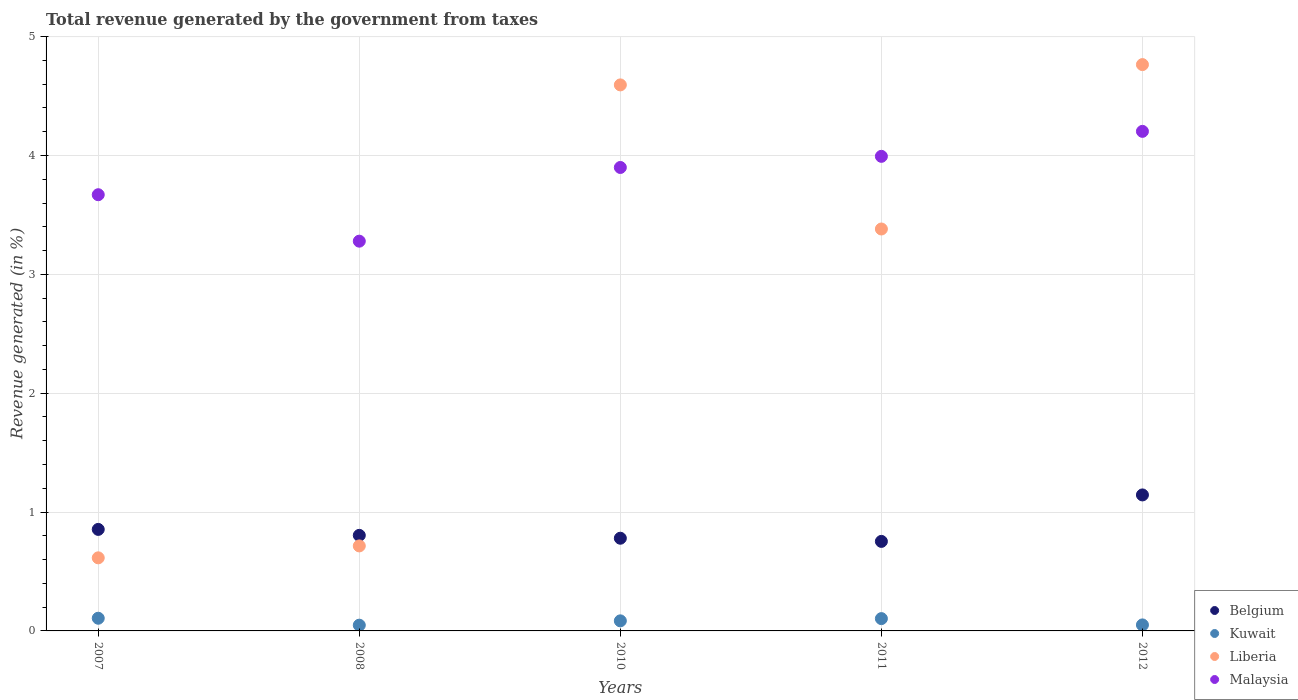Is the number of dotlines equal to the number of legend labels?
Provide a short and direct response. Yes. What is the total revenue generated in Malaysia in 2012?
Provide a short and direct response. 4.2. Across all years, what is the maximum total revenue generated in Belgium?
Give a very brief answer. 1.14. Across all years, what is the minimum total revenue generated in Kuwait?
Keep it short and to the point. 0.05. In which year was the total revenue generated in Belgium minimum?
Offer a terse response. 2011. What is the total total revenue generated in Liberia in the graph?
Provide a succinct answer. 14.07. What is the difference between the total revenue generated in Malaysia in 2008 and that in 2010?
Make the answer very short. -0.62. What is the difference between the total revenue generated in Belgium in 2011 and the total revenue generated in Kuwait in 2012?
Provide a succinct answer. 0.7. What is the average total revenue generated in Malaysia per year?
Your answer should be very brief. 3.81. In the year 2012, what is the difference between the total revenue generated in Malaysia and total revenue generated in Kuwait?
Ensure brevity in your answer.  4.15. In how many years, is the total revenue generated in Belgium greater than 2 %?
Ensure brevity in your answer.  0. What is the ratio of the total revenue generated in Kuwait in 2011 to that in 2012?
Your answer should be compact. 2.05. Is the total revenue generated in Belgium in 2008 less than that in 2012?
Your answer should be very brief. Yes. What is the difference between the highest and the second highest total revenue generated in Malaysia?
Make the answer very short. 0.21. What is the difference between the highest and the lowest total revenue generated in Kuwait?
Keep it short and to the point. 0.06. Is the sum of the total revenue generated in Belgium in 2011 and 2012 greater than the maximum total revenue generated in Malaysia across all years?
Offer a very short reply. No. Is it the case that in every year, the sum of the total revenue generated in Liberia and total revenue generated in Kuwait  is greater than the total revenue generated in Malaysia?
Your answer should be very brief. No. Is the total revenue generated in Belgium strictly less than the total revenue generated in Malaysia over the years?
Give a very brief answer. Yes. How many years are there in the graph?
Your answer should be compact. 5. Does the graph contain any zero values?
Offer a terse response. No. Does the graph contain grids?
Keep it short and to the point. Yes. Where does the legend appear in the graph?
Ensure brevity in your answer.  Bottom right. What is the title of the graph?
Provide a short and direct response. Total revenue generated by the government from taxes. What is the label or title of the Y-axis?
Your response must be concise. Revenue generated (in %). What is the Revenue generated (in %) of Belgium in 2007?
Your answer should be compact. 0.85. What is the Revenue generated (in %) of Kuwait in 2007?
Provide a short and direct response. 0.11. What is the Revenue generated (in %) of Liberia in 2007?
Your answer should be compact. 0.61. What is the Revenue generated (in %) of Malaysia in 2007?
Your answer should be very brief. 3.67. What is the Revenue generated (in %) of Belgium in 2008?
Offer a very short reply. 0.8. What is the Revenue generated (in %) of Kuwait in 2008?
Provide a succinct answer. 0.05. What is the Revenue generated (in %) in Liberia in 2008?
Give a very brief answer. 0.72. What is the Revenue generated (in %) in Malaysia in 2008?
Keep it short and to the point. 3.28. What is the Revenue generated (in %) of Belgium in 2010?
Make the answer very short. 0.78. What is the Revenue generated (in %) of Kuwait in 2010?
Provide a short and direct response. 0.08. What is the Revenue generated (in %) in Liberia in 2010?
Keep it short and to the point. 4.59. What is the Revenue generated (in %) in Malaysia in 2010?
Make the answer very short. 3.9. What is the Revenue generated (in %) of Belgium in 2011?
Give a very brief answer. 0.75. What is the Revenue generated (in %) of Kuwait in 2011?
Keep it short and to the point. 0.1. What is the Revenue generated (in %) of Liberia in 2011?
Give a very brief answer. 3.38. What is the Revenue generated (in %) of Malaysia in 2011?
Provide a short and direct response. 3.99. What is the Revenue generated (in %) of Belgium in 2012?
Ensure brevity in your answer.  1.14. What is the Revenue generated (in %) in Kuwait in 2012?
Provide a succinct answer. 0.05. What is the Revenue generated (in %) of Liberia in 2012?
Keep it short and to the point. 4.76. What is the Revenue generated (in %) of Malaysia in 2012?
Offer a terse response. 4.2. Across all years, what is the maximum Revenue generated (in %) of Belgium?
Your answer should be compact. 1.14. Across all years, what is the maximum Revenue generated (in %) in Kuwait?
Ensure brevity in your answer.  0.11. Across all years, what is the maximum Revenue generated (in %) in Liberia?
Keep it short and to the point. 4.76. Across all years, what is the maximum Revenue generated (in %) in Malaysia?
Your answer should be compact. 4.2. Across all years, what is the minimum Revenue generated (in %) of Belgium?
Offer a very short reply. 0.75. Across all years, what is the minimum Revenue generated (in %) in Kuwait?
Ensure brevity in your answer.  0.05. Across all years, what is the minimum Revenue generated (in %) of Liberia?
Keep it short and to the point. 0.61. Across all years, what is the minimum Revenue generated (in %) of Malaysia?
Your response must be concise. 3.28. What is the total Revenue generated (in %) of Belgium in the graph?
Keep it short and to the point. 4.34. What is the total Revenue generated (in %) of Kuwait in the graph?
Provide a succinct answer. 0.39. What is the total Revenue generated (in %) of Liberia in the graph?
Your answer should be very brief. 14.07. What is the total Revenue generated (in %) of Malaysia in the graph?
Make the answer very short. 19.04. What is the difference between the Revenue generated (in %) of Belgium in 2007 and that in 2008?
Ensure brevity in your answer.  0.05. What is the difference between the Revenue generated (in %) of Kuwait in 2007 and that in 2008?
Keep it short and to the point. 0.06. What is the difference between the Revenue generated (in %) of Liberia in 2007 and that in 2008?
Offer a terse response. -0.1. What is the difference between the Revenue generated (in %) in Malaysia in 2007 and that in 2008?
Your response must be concise. 0.39. What is the difference between the Revenue generated (in %) in Belgium in 2007 and that in 2010?
Keep it short and to the point. 0.07. What is the difference between the Revenue generated (in %) of Kuwait in 2007 and that in 2010?
Your answer should be very brief. 0.02. What is the difference between the Revenue generated (in %) of Liberia in 2007 and that in 2010?
Your answer should be compact. -3.98. What is the difference between the Revenue generated (in %) of Malaysia in 2007 and that in 2010?
Provide a short and direct response. -0.23. What is the difference between the Revenue generated (in %) of Belgium in 2007 and that in 2011?
Offer a very short reply. 0.1. What is the difference between the Revenue generated (in %) in Kuwait in 2007 and that in 2011?
Make the answer very short. 0. What is the difference between the Revenue generated (in %) in Liberia in 2007 and that in 2011?
Your answer should be compact. -2.77. What is the difference between the Revenue generated (in %) of Malaysia in 2007 and that in 2011?
Give a very brief answer. -0.32. What is the difference between the Revenue generated (in %) of Belgium in 2007 and that in 2012?
Provide a short and direct response. -0.29. What is the difference between the Revenue generated (in %) in Kuwait in 2007 and that in 2012?
Give a very brief answer. 0.06. What is the difference between the Revenue generated (in %) of Liberia in 2007 and that in 2012?
Make the answer very short. -4.15. What is the difference between the Revenue generated (in %) of Malaysia in 2007 and that in 2012?
Give a very brief answer. -0.53. What is the difference between the Revenue generated (in %) in Belgium in 2008 and that in 2010?
Provide a succinct answer. 0.02. What is the difference between the Revenue generated (in %) of Kuwait in 2008 and that in 2010?
Provide a short and direct response. -0.04. What is the difference between the Revenue generated (in %) of Liberia in 2008 and that in 2010?
Make the answer very short. -3.88. What is the difference between the Revenue generated (in %) in Malaysia in 2008 and that in 2010?
Offer a terse response. -0.62. What is the difference between the Revenue generated (in %) in Belgium in 2008 and that in 2011?
Provide a short and direct response. 0.05. What is the difference between the Revenue generated (in %) in Kuwait in 2008 and that in 2011?
Offer a very short reply. -0.06. What is the difference between the Revenue generated (in %) of Liberia in 2008 and that in 2011?
Provide a short and direct response. -2.67. What is the difference between the Revenue generated (in %) of Malaysia in 2008 and that in 2011?
Make the answer very short. -0.71. What is the difference between the Revenue generated (in %) in Belgium in 2008 and that in 2012?
Give a very brief answer. -0.34. What is the difference between the Revenue generated (in %) in Kuwait in 2008 and that in 2012?
Give a very brief answer. -0. What is the difference between the Revenue generated (in %) in Liberia in 2008 and that in 2012?
Your answer should be very brief. -4.05. What is the difference between the Revenue generated (in %) in Malaysia in 2008 and that in 2012?
Offer a terse response. -0.92. What is the difference between the Revenue generated (in %) in Belgium in 2010 and that in 2011?
Provide a succinct answer. 0.03. What is the difference between the Revenue generated (in %) in Kuwait in 2010 and that in 2011?
Make the answer very short. -0.02. What is the difference between the Revenue generated (in %) in Liberia in 2010 and that in 2011?
Provide a short and direct response. 1.21. What is the difference between the Revenue generated (in %) in Malaysia in 2010 and that in 2011?
Your answer should be very brief. -0.09. What is the difference between the Revenue generated (in %) in Belgium in 2010 and that in 2012?
Ensure brevity in your answer.  -0.36. What is the difference between the Revenue generated (in %) of Kuwait in 2010 and that in 2012?
Your response must be concise. 0.03. What is the difference between the Revenue generated (in %) of Liberia in 2010 and that in 2012?
Provide a succinct answer. -0.17. What is the difference between the Revenue generated (in %) in Malaysia in 2010 and that in 2012?
Keep it short and to the point. -0.3. What is the difference between the Revenue generated (in %) in Belgium in 2011 and that in 2012?
Provide a succinct answer. -0.39. What is the difference between the Revenue generated (in %) of Kuwait in 2011 and that in 2012?
Your answer should be compact. 0.05. What is the difference between the Revenue generated (in %) of Liberia in 2011 and that in 2012?
Keep it short and to the point. -1.38. What is the difference between the Revenue generated (in %) of Malaysia in 2011 and that in 2012?
Your response must be concise. -0.21. What is the difference between the Revenue generated (in %) in Belgium in 2007 and the Revenue generated (in %) in Kuwait in 2008?
Your answer should be very brief. 0.81. What is the difference between the Revenue generated (in %) of Belgium in 2007 and the Revenue generated (in %) of Liberia in 2008?
Your response must be concise. 0.14. What is the difference between the Revenue generated (in %) of Belgium in 2007 and the Revenue generated (in %) of Malaysia in 2008?
Your answer should be compact. -2.42. What is the difference between the Revenue generated (in %) of Kuwait in 2007 and the Revenue generated (in %) of Liberia in 2008?
Provide a succinct answer. -0.61. What is the difference between the Revenue generated (in %) in Kuwait in 2007 and the Revenue generated (in %) in Malaysia in 2008?
Provide a short and direct response. -3.17. What is the difference between the Revenue generated (in %) of Liberia in 2007 and the Revenue generated (in %) of Malaysia in 2008?
Your answer should be compact. -2.66. What is the difference between the Revenue generated (in %) of Belgium in 2007 and the Revenue generated (in %) of Kuwait in 2010?
Your response must be concise. 0.77. What is the difference between the Revenue generated (in %) in Belgium in 2007 and the Revenue generated (in %) in Liberia in 2010?
Keep it short and to the point. -3.74. What is the difference between the Revenue generated (in %) in Belgium in 2007 and the Revenue generated (in %) in Malaysia in 2010?
Make the answer very short. -3.04. What is the difference between the Revenue generated (in %) in Kuwait in 2007 and the Revenue generated (in %) in Liberia in 2010?
Keep it short and to the point. -4.49. What is the difference between the Revenue generated (in %) of Kuwait in 2007 and the Revenue generated (in %) of Malaysia in 2010?
Your response must be concise. -3.79. What is the difference between the Revenue generated (in %) of Liberia in 2007 and the Revenue generated (in %) of Malaysia in 2010?
Offer a terse response. -3.28. What is the difference between the Revenue generated (in %) of Belgium in 2007 and the Revenue generated (in %) of Kuwait in 2011?
Keep it short and to the point. 0.75. What is the difference between the Revenue generated (in %) in Belgium in 2007 and the Revenue generated (in %) in Liberia in 2011?
Your answer should be compact. -2.53. What is the difference between the Revenue generated (in %) of Belgium in 2007 and the Revenue generated (in %) of Malaysia in 2011?
Ensure brevity in your answer.  -3.14. What is the difference between the Revenue generated (in %) of Kuwait in 2007 and the Revenue generated (in %) of Liberia in 2011?
Offer a very short reply. -3.27. What is the difference between the Revenue generated (in %) in Kuwait in 2007 and the Revenue generated (in %) in Malaysia in 2011?
Offer a very short reply. -3.89. What is the difference between the Revenue generated (in %) in Liberia in 2007 and the Revenue generated (in %) in Malaysia in 2011?
Offer a terse response. -3.38. What is the difference between the Revenue generated (in %) in Belgium in 2007 and the Revenue generated (in %) in Kuwait in 2012?
Offer a very short reply. 0.8. What is the difference between the Revenue generated (in %) of Belgium in 2007 and the Revenue generated (in %) of Liberia in 2012?
Provide a succinct answer. -3.91. What is the difference between the Revenue generated (in %) of Belgium in 2007 and the Revenue generated (in %) of Malaysia in 2012?
Ensure brevity in your answer.  -3.35. What is the difference between the Revenue generated (in %) of Kuwait in 2007 and the Revenue generated (in %) of Liberia in 2012?
Your answer should be very brief. -4.66. What is the difference between the Revenue generated (in %) of Kuwait in 2007 and the Revenue generated (in %) of Malaysia in 2012?
Give a very brief answer. -4.1. What is the difference between the Revenue generated (in %) in Liberia in 2007 and the Revenue generated (in %) in Malaysia in 2012?
Your answer should be very brief. -3.59. What is the difference between the Revenue generated (in %) in Belgium in 2008 and the Revenue generated (in %) in Kuwait in 2010?
Your response must be concise. 0.72. What is the difference between the Revenue generated (in %) of Belgium in 2008 and the Revenue generated (in %) of Liberia in 2010?
Provide a short and direct response. -3.79. What is the difference between the Revenue generated (in %) of Belgium in 2008 and the Revenue generated (in %) of Malaysia in 2010?
Your answer should be compact. -3.09. What is the difference between the Revenue generated (in %) in Kuwait in 2008 and the Revenue generated (in %) in Liberia in 2010?
Keep it short and to the point. -4.55. What is the difference between the Revenue generated (in %) in Kuwait in 2008 and the Revenue generated (in %) in Malaysia in 2010?
Provide a short and direct response. -3.85. What is the difference between the Revenue generated (in %) in Liberia in 2008 and the Revenue generated (in %) in Malaysia in 2010?
Your answer should be compact. -3.18. What is the difference between the Revenue generated (in %) of Belgium in 2008 and the Revenue generated (in %) of Kuwait in 2011?
Make the answer very short. 0.7. What is the difference between the Revenue generated (in %) in Belgium in 2008 and the Revenue generated (in %) in Liberia in 2011?
Make the answer very short. -2.58. What is the difference between the Revenue generated (in %) of Belgium in 2008 and the Revenue generated (in %) of Malaysia in 2011?
Your response must be concise. -3.19. What is the difference between the Revenue generated (in %) of Kuwait in 2008 and the Revenue generated (in %) of Liberia in 2011?
Your response must be concise. -3.33. What is the difference between the Revenue generated (in %) in Kuwait in 2008 and the Revenue generated (in %) in Malaysia in 2011?
Provide a short and direct response. -3.94. What is the difference between the Revenue generated (in %) of Liberia in 2008 and the Revenue generated (in %) of Malaysia in 2011?
Your answer should be compact. -3.28. What is the difference between the Revenue generated (in %) of Belgium in 2008 and the Revenue generated (in %) of Kuwait in 2012?
Your answer should be very brief. 0.75. What is the difference between the Revenue generated (in %) in Belgium in 2008 and the Revenue generated (in %) in Liberia in 2012?
Offer a terse response. -3.96. What is the difference between the Revenue generated (in %) of Belgium in 2008 and the Revenue generated (in %) of Malaysia in 2012?
Ensure brevity in your answer.  -3.4. What is the difference between the Revenue generated (in %) in Kuwait in 2008 and the Revenue generated (in %) in Liberia in 2012?
Your answer should be compact. -4.72. What is the difference between the Revenue generated (in %) in Kuwait in 2008 and the Revenue generated (in %) in Malaysia in 2012?
Your response must be concise. -4.15. What is the difference between the Revenue generated (in %) of Liberia in 2008 and the Revenue generated (in %) of Malaysia in 2012?
Provide a succinct answer. -3.49. What is the difference between the Revenue generated (in %) of Belgium in 2010 and the Revenue generated (in %) of Kuwait in 2011?
Make the answer very short. 0.68. What is the difference between the Revenue generated (in %) in Belgium in 2010 and the Revenue generated (in %) in Liberia in 2011?
Give a very brief answer. -2.6. What is the difference between the Revenue generated (in %) in Belgium in 2010 and the Revenue generated (in %) in Malaysia in 2011?
Give a very brief answer. -3.21. What is the difference between the Revenue generated (in %) in Kuwait in 2010 and the Revenue generated (in %) in Liberia in 2011?
Your answer should be very brief. -3.3. What is the difference between the Revenue generated (in %) of Kuwait in 2010 and the Revenue generated (in %) of Malaysia in 2011?
Make the answer very short. -3.91. What is the difference between the Revenue generated (in %) of Liberia in 2010 and the Revenue generated (in %) of Malaysia in 2011?
Your answer should be very brief. 0.6. What is the difference between the Revenue generated (in %) in Belgium in 2010 and the Revenue generated (in %) in Kuwait in 2012?
Ensure brevity in your answer.  0.73. What is the difference between the Revenue generated (in %) in Belgium in 2010 and the Revenue generated (in %) in Liberia in 2012?
Your answer should be very brief. -3.98. What is the difference between the Revenue generated (in %) of Belgium in 2010 and the Revenue generated (in %) of Malaysia in 2012?
Ensure brevity in your answer.  -3.42. What is the difference between the Revenue generated (in %) of Kuwait in 2010 and the Revenue generated (in %) of Liberia in 2012?
Offer a very short reply. -4.68. What is the difference between the Revenue generated (in %) of Kuwait in 2010 and the Revenue generated (in %) of Malaysia in 2012?
Give a very brief answer. -4.12. What is the difference between the Revenue generated (in %) in Liberia in 2010 and the Revenue generated (in %) in Malaysia in 2012?
Your answer should be very brief. 0.39. What is the difference between the Revenue generated (in %) of Belgium in 2011 and the Revenue generated (in %) of Kuwait in 2012?
Make the answer very short. 0.7. What is the difference between the Revenue generated (in %) of Belgium in 2011 and the Revenue generated (in %) of Liberia in 2012?
Provide a succinct answer. -4.01. What is the difference between the Revenue generated (in %) in Belgium in 2011 and the Revenue generated (in %) in Malaysia in 2012?
Give a very brief answer. -3.45. What is the difference between the Revenue generated (in %) in Kuwait in 2011 and the Revenue generated (in %) in Liberia in 2012?
Your answer should be very brief. -4.66. What is the difference between the Revenue generated (in %) in Kuwait in 2011 and the Revenue generated (in %) in Malaysia in 2012?
Your answer should be compact. -4.1. What is the difference between the Revenue generated (in %) of Liberia in 2011 and the Revenue generated (in %) of Malaysia in 2012?
Make the answer very short. -0.82. What is the average Revenue generated (in %) in Belgium per year?
Your answer should be compact. 0.87. What is the average Revenue generated (in %) in Kuwait per year?
Provide a succinct answer. 0.08. What is the average Revenue generated (in %) in Liberia per year?
Ensure brevity in your answer.  2.81. What is the average Revenue generated (in %) in Malaysia per year?
Offer a terse response. 3.81. In the year 2007, what is the difference between the Revenue generated (in %) of Belgium and Revenue generated (in %) of Kuwait?
Ensure brevity in your answer.  0.75. In the year 2007, what is the difference between the Revenue generated (in %) of Belgium and Revenue generated (in %) of Liberia?
Give a very brief answer. 0.24. In the year 2007, what is the difference between the Revenue generated (in %) in Belgium and Revenue generated (in %) in Malaysia?
Give a very brief answer. -2.82. In the year 2007, what is the difference between the Revenue generated (in %) in Kuwait and Revenue generated (in %) in Liberia?
Ensure brevity in your answer.  -0.51. In the year 2007, what is the difference between the Revenue generated (in %) in Kuwait and Revenue generated (in %) in Malaysia?
Make the answer very short. -3.56. In the year 2007, what is the difference between the Revenue generated (in %) in Liberia and Revenue generated (in %) in Malaysia?
Keep it short and to the point. -3.05. In the year 2008, what is the difference between the Revenue generated (in %) in Belgium and Revenue generated (in %) in Kuwait?
Provide a short and direct response. 0.76. In the year 2008, what is the difference between the Revenue generated (in %) of Belgium and Revenue generated (in %) of Liberia?
Your response must be concise. 0.09. In the year 2008, what is the difference between the Revenue generated (in %) in Belgium and Revenue generated (in %) in Malaysia?
Provide a succinct answer. -2.47. In the year 2008, what is the difference between the Revenue generated (in %) of Kuwait and Revenue generated (in %) of Liberia?
Offer a very short reply. -0.67. In the year 2008, what is the difference between the Revenue generated (in %) of Kuwait and Revenue generated (in %) of Malaysia?
Make the answer very short. -3.23. In the year 2008, what is the difference between the Revenue generated (in %) in Liberia and Revenue generated (in %) in Malaysia?
Provide a succinct answer. -2.56. In the year 2010, what is the difference between the Revenue generated (in %) in Belgium and Revenue generated (in %) in Kuwait?
Give a very brief answer. 0.7. In the year 2010, what is the difference between the Revenue generated (in %) of Belgium and Revenue generated (in %) of Liberia?
Offer a very short reply. -3.81. In the year 2010, what is the difference between the Revenue generated (in %) in Belgium and Revenue generated (in %) in Malaysia?
Give a very brief answer. -3.12. In the year 2010, what is the difference between the Revenue generated (in %) in Kuwait and Revenue generated (in %) in Liberia?
Offer a very short reply. -4.51. In the year 2010, what is the difference between the Revenue generated (in %) of Kuwait and Revenue generated (in %) of Malaysia?
Provide a short and direct response. -3.81. In the year 2010, what is the difference between the Revenue generated (in %) of Liberia and Revenue generated (in %) of Malaysia?
Your answer should be very brief. 0.69. In the year 2011, what is the difference between the Revenue generated (in %) of Belgium and Revenue generated (in %) of Kuwait?
Your answer should be very brief. 0.65. In the year 2011, what is the difference between the Revenue generated (in %) in Belgium and Revenue generated (in %) in Liberia?
Provide a short and direct response. -2.63. In the year 2011, what is the difference between the Revenue generated (in %) of Belgium and Revenue generated (in %) of Malaysia?
Ensure brevity in your answer.  -3.24. In the year 2011, what is the difference between the Revenue generated (in %) in Kuwait and Revenue generated (in %) in Liberia?
Your response must be concise. -3.28. In the year 2011, what is the difference between the Revenue generated (in %) of Kuwait and Revenue generated (in %) of Malaysia?
Provide a succinct answer. -3.89. In the year 2011, what is the difference between the Revenue generated (in %) in Liberia and Revenue generated (in %) in Malaysia?
Offer a terse response. -0.61. In the year 2012, what is the difference between the Revenue generated (in %) of Belgium and Revenue generated (in %) of Kuwait?
Provide a short and direct response. 1.09. In the year 2012, what is the difference between the Revenue generated (in %) in Belgium and Revenue generated (in %) in Liberia?
Provide a short and direct response. -3.62. In the year 2012, what is the difference between the Revenue generated (in %) in Belgium and Revenue generated (in %) in Malaysia?
Make the answer very short. -3.06. In the year 2012, what is the difference between the Revenue generated (in %) of Kuwait and Revenue generated (in %) of Liberia?
Your answer should be very brief. -4.71. In the year 2012, what is the difference between the Revenue generated (in %) in Kuwait and Revenue generated (in %) in Malaysia?
Offer a very short reply. -4.15. In the year 2012, what is the difference between the Revenue generated (in %) of Liberia and Revenue generated (in %) of Malaysia?
Give a very brief answer. 0.56. What is the ratio of the Revenue generated (in %) of Belgium in 2007 to that in 2008?
Make the answer very short. 1.06. What is the ratio of the Revenue generated (in %) in Kuwait in 2007 to that in 2008?
Keep it short and to the point. 2.21. What is the ratio of the Revenue generated (in %) of Liberia in 2007 to that in 2008?
Your response must be concise. 0.86. What is the ratio of the Revenue generated (in %) of Malaysia in 2007 to that in 2008?
Your answer should be very brief. 1.12. What is the ratio of the Revenue generated (in %) in Belgium in 2007 to that in 2010?
Provide a short and direct response. 1.1. What is the ratio of the Revenue generated (in %) of Kuwait in 2007 to that in 2010?
Keep it short and to the point. 1.26. What is the ratio of the Revenue generated (in %) in Liberia in 2007 to that in 2010?
Your answer should be very brief. 0.13. What is the ratio of the Revenue generated (in %) of Belgium in 2007 to that in 2011?
Your response must be concise. 1.13. What is the ratio of the Revenue generated (in %) of Kuwait in 2007 to that in 2011?
Make the answer very short. 1.03. What is the ratio of the Revenue generated (in %) of Liberia in 2007 to that in 2011?
Make the answer very short. 0.18. What is the ratio of the Revenue generated (in %) of Malaysia in 2007 to that in 2011?
Offer a very short reply. 0.92. What is the ratio of the Revenue generated (in %) in Belgium in 2007 to that in 2012?
Your answer should be very brief. 0.75. What is the ratio of the Revenue generated (in %) in Kuwait in 2007 to that in 2012?
Your response must be concise. 2.11. What is the ratio of the Revenue generated (in %) in Liberia in 2007 to that in 2012?
Give a very brief answer. 0.13. What is the ratio of the Revenue generated (in %) of Malaysia in 2007 to that in 2012?
Give a very brief answer. 0.87. What is the ratio of the Revenue generated (in %) in Belgium in 2008 to that in 2010?
Your answer should be very brief. 1.03. What is the ratio of the Revenue generated (in %) in Kuwait in 2008 to that in 2010?
Your answer should be very brief. 0.57. What is the ratio of the Revenue generated (in %) of Liberia in 2008 to that in 2010?
Provide a succinct answer. 0.16. What is the ratio of the Revenue generated (in %) in Malaysia in 2008 to that in 2010?
Your response must be concise. 0.84. What is the ratio of the Revenue generated (in %) of Belgium in 2008 to that in 2011?
Make the answer very short. 1.07. What is the ratio of the Revenue generated (in %) of Kuwait in 2008 to that in 2011?
Provide a succinct answer. 0.47. What is the ratio of the Revenue generated (in %) in Liberia in 2008 to that in 2011?
Give a very brief answer. 0.21. What is the ratio of the Revenue generated (in %) in Malaysia in 2008 to that in 2011?
Ensure brevity in your answer.  0.82. What is the ratio of the Revenue generated (in %) in Belgium in 2008 to that in 2012?
Your response must be concise. 0.7. What is the ratio of the Revenue generated (in %) of Kuwait in 2008 to that in 2012?
Provide a short and direct response. 0.95. What is the ratio of the Revenue generated (in %) in Liberia in 2008 to that in 2012?
Give a very brief answer. 0.15. What is the ratio of the Revenue generated (in %) in Malaysia in 2008 to that in 2012?
Ensure brevity in your answer.  0.78. What is the ratio of the Revenue generated (in %) in Belgium in 2010 to that in 2011?
Provide a short and direct response. 1.04. What is the ratio of the Revenue generated (in %) of Kuwait in 2010 to that in 2011?
Your answer should be compact. 0.82. What is the ratio of the Revenue generated (in %) in Liberia in 2010 to that in 2011?
Provide a succinct answer. 1.36. What is the ratio of the Revenue generated (in %) in Malaysia in 2010 to that in 2011?
Offer a very short reply. 0.98. What is the ratio of the Revenue generated (in %) in Belgium in 2010 to that in 2012?
Ensure brevity in your answer.  0.68. What is the ratio of the Revenue generated (in %) of Kuwait in 2010 to that in 2012?
Offer a terse response. 1.68. What is the ratio of the Revenue generated (in %) in Liberia in 2010 to that in 2012?
Provide a short and direct response. 0.96. What is the ratio of the Revenue generated (in %) in Malaysia in 2010 to that in 2012?
Ensure brevity in your answer.  0.93. What is the ratio of the Revenue generated (in %) in Belgium in 2011 to that in 2012?
Ensure brevity in your answer.  0.66. What is the ratio of the Revenue generated (in %) of Kuwait in 2011 to that in 2012?
Make the answer very short. 2.05. What is the ratio of the Revenue generated (in %) of Liberia in 2011 to that in 2012?
Ensure brevity in your answer.  0.71. What is the ratio of the Revenue generated (in %) in Malaysia in 2011 to that in 2012?
Your answer should be very brief. 0.95. What is the difference between the highest and the second highest Revenue generated (in %) of Belgium?
Give a very brief answer. 0.29. What is the difference between the highest and the second highest Revenue generated (in %) in Kuwait?
Ensure brevity in your answer.  0. What is the difference between the highest and the second highest Revenue generated (in %) in Liberia?
Offer a terse response. 0.17. What is the difference between the highest and the second highest Revenue generated (in %) in Malaysia?
Ensure brevity in your answer.  0.21. What is the difference between the highest and the lowest Revenue generated (in %) of Belgium?
Provide a succinct answer. 0.39. What is the difference between the highest and the lowest Revenue generated (in %) in Kuwait?
Give a very brief answer. 0.06. What is the difference between the highest and the lowest Revenue generated (in %) of Liberia?
Ensure brevity in your answer.  4.15. What is the difference between the highest and the lowest Revenue generated (in %) in Malaysia?
Offer a very short reply. 0.92. 